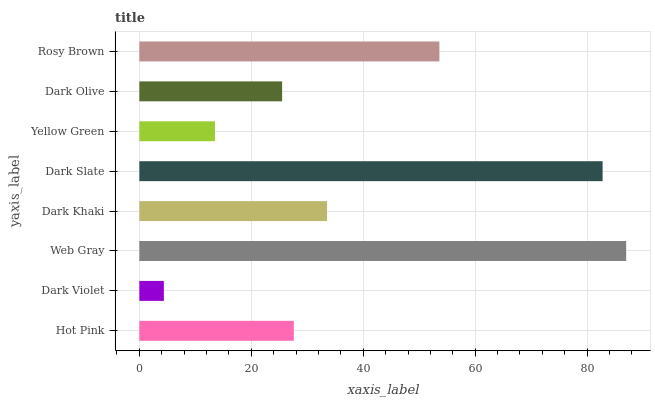Is Dark Violet the minimum?
Answer yes or no. Yes. Is Web Gray the maximum?
Answer yes or no. Yes. Is Web Gray the minimum?
Answer yes or no. No. Is Dark Violet the maximum?
Answer yes or no. No. Is Web Gray greater than Dark Violet?
Answer yes or no. Yes. Is Dark Violet less than Web Gray?
Answer yes or no. Yes. Is Dark Violet greater than Web Gray?
Answer yes or no. No. Is Web Gray less than Dark Violet?
Answer yes or no. No. Is Dark Khaki the high median?
Answer yes or no. Yes. Is Hot Pink the low median?
Answer yes or no. Yes. Is Dark Violet the high median?
Answer yes or no. No. Is Dark Khaki the low median?
Answer yes or no. No. 